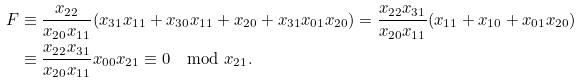Convert formula to latex. <formula><loc_0><loc_0><loc_500><loc_500>F & \equiv \frac { x _ { 2 2 } } { x _ { 2 0 } x _ { 1 1 } } ( x _ { 3 1 } x _ { 1 1 } + x _ { 3 0 } x _ { 1 1 } + x _ { 2 0 } + x _ { 3 1 } x _ { 0 1 } x _ { 2 0 } ) = \frac { x _ { 2 2 } x _ { 3 1 } } { x _ { 2 0 } x _ { 1 1 } } ( x _ { 1 1 } + x _ { 1 0 } + x _ { 0 1 } x _ { 2 0 } ) \\ & \equiv \frac { x _ { 2 2 } x _ { 3 1 } } { x _ { 2 0 } x _ { 1 1 } } x _ { 0 0 } x _ { 2 1 } \equiv 0 \mod x _ { 2 1 } .</formula> 